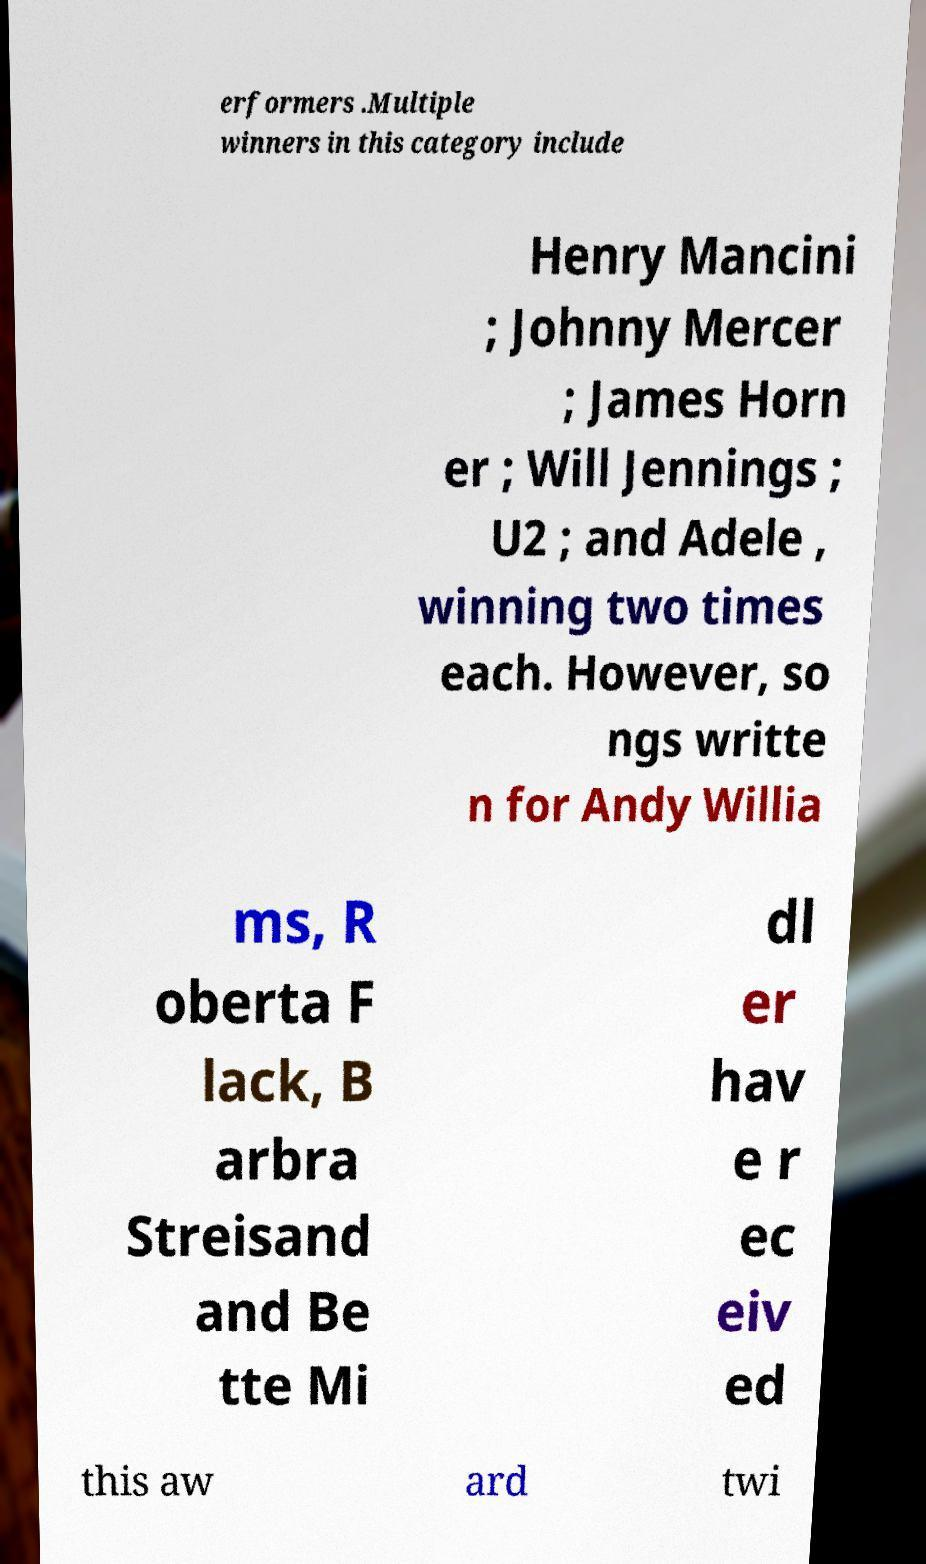For documentation purposes, I need the text within this image transcribed. Could you provide that? erformers .Multiple winners in this category include Henry Mancini ; Johnny Mercer ; James Horn er ; Will Jennings ; U2 ; and Adele , winning two times each. However, so ngs writte n for Andy Willia ms, R oberta F lack, B arbra Streisand and Be tte Mi dl er hav e r ec eiv ed this aw ard twi 